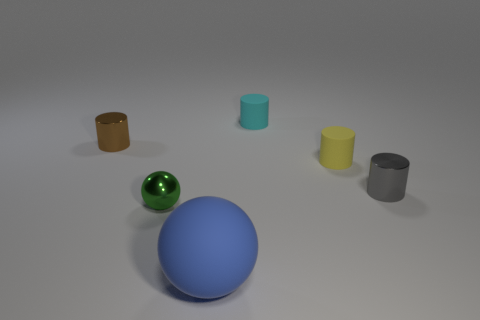What is the shape of the tiny thing that is in front of the small cylinder that is in front of the yellow thing?
Your answer should be very brief. Sphere. Is there anything else that has the same shape as the large blue matte thing?
Your answer should be compact. Yes. The other small metal thing that is the same shape as the blue object is what color?
Give a very brief answer. Green. Is the color of the small metal ball the same as the tiny metallic cylinder that is right of the green sphere?
Your answer should be compact. No. There is a thing that is in front of the tiny gray thing and to the right of the small green shiny object; what shape is it?
Make the answer very short. Sphere. Is the number of small green metal objects less than the number of big cyan metal blocks?
Offer a terse response. No. Are any big yellow shiny blocks visible?
Give a very brief answer. No. What number of other things are the same size as the metallic ball?
Your answer should be very brief. 4. Do the small brown object and the ball behind the large thing have the same material?
Offer a terse response. Yes. Is the number of big blue matte spheres that are behind the gray metallic cylinder the same as the number of spheres that are in front of the big blue matte sphere?
Provide a short and direct response. Yes. 